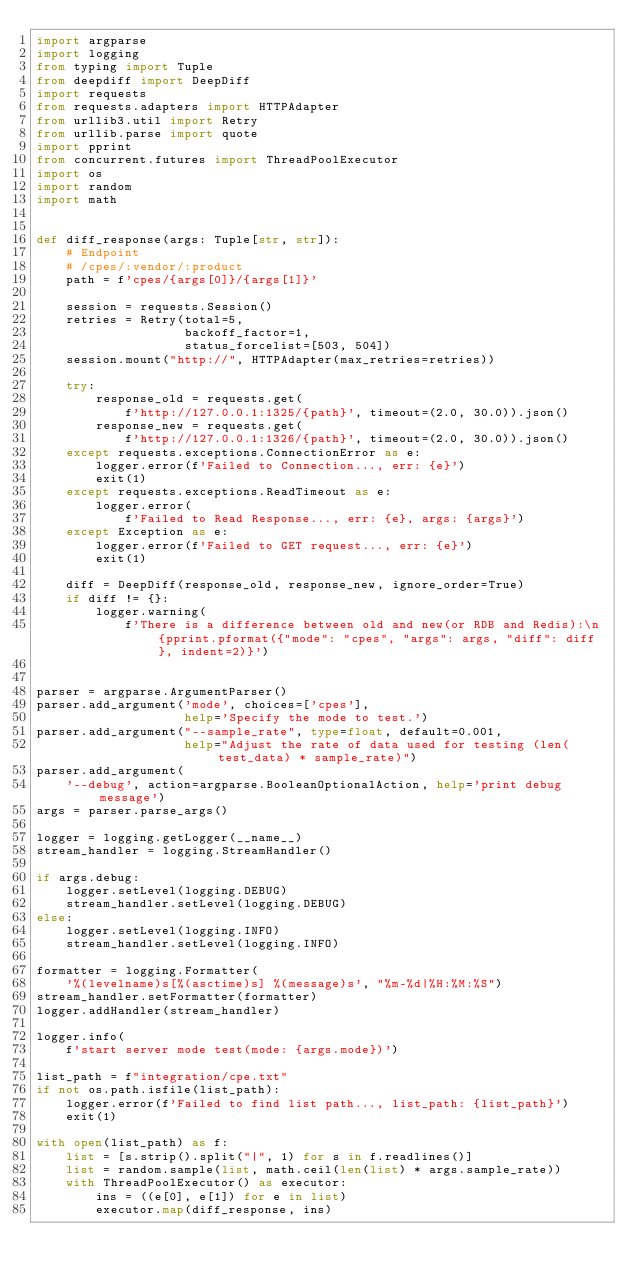<code> <loc_0><loc_0><loc_500><loc_500><_Python_>import argparse
import logging
from typing import Tuple
from deepdiff import DeepDiff
import requests
from requests.adapters import HTTPAdapter
from urllib3.util import Retry
from urllib.parse import quote
import pprint
from concurrent.futures import ThreadPoolExecutor
import os
import random
import math


def diff_response(args: Tuple[str, str]):
    # Endpoint
    # /cpes/:vendor/:product
    path = f'cpes/{args[0]}/{args[1]}'

    session = requests.Session()
    retries = Retry(total=5,
                    backoff_factor=1,
                    status_forcelist=[503, 504])
    session.mount("http://", HTTPAdapter(max_retries=retries))

    try:
        response_old = requests.get(
            f'http://127.0.0.1:1325/{path}', timeout=(2.0, 30.0)).json()
        response_new = requests.get(
            f'http://127.0.0.1:1326/{path}', timeout=(2.0, 30.0)).json()
    except requests.exceptions.ConnectionError as e:
        logger.error(f'Failed to Connection..., err: {e}')
        exit(1)
    except requests.exceptions.ReadTimeout as e:
        logger.error(
            f'Failed to Read Response..., err: {e}, args: {args}')
    except Exception as e:
        logger.error(f'Failed to GET request..., err: {e}')
        exit(1)

    diff = DeepDiff(response_old, response_new, ignore_order=True)
    if diff != {}:
        logger.warning(
            f'There is a difference between old and new(or RDB and Redis):\n {pprint.pformat({"mode": "cpes", "args": args, "diff": diff}, indent=2)}')


parser = argparse.ArgumentParser()
parser.add_argument('mode', choices=['cpes'],
                    help='Specify the mode to test.')
parser.add_argument("--sample_rate", type=float, default=0.001,
                    help="Adjust the rate of data used for testing (len(test_data) * sample_rate)")
parser.add_argument(
    '--debug', action=argparse.BooleanOptionalAction, help='print debug message')
args = parser.parse_args()

logger = logging.getLogger(__name__)
stream_handler = logging.StreamHandler()

if args.debug:
    logger.setLevel(logging.DEBUG)
    stream_handler.setLevel(logging.DEBUG)
else:
    logger.setLevel(logging.INFO)
    stream_handler.setLevel(logging.INFO)

formatter = logging.Formatter(
    '%(levelname)s[%(asctime)s] %(message)s', "%m-%d|%H:%M:%S")
stream_handler.setFormatter(formatter)
logger.addHandler(stream_handler)

logger.info(
    f'start server mode test(mode: {args.mode})')

list_path = f"integration/cpe.txt"
if not os.path.isfile(list_path):
    logger.error(f'Failed to find list path..., list_path: {list_path}')
    exit(1)

with open(list_path) as f:
    list = [s.strip().split("|", 1) for s in f.readlines()]
    list = random.sample(list, math.ceil(len(list) * args.sample_rate))
    with ThreadPoolExecutor() as executor:
        ins = ((e[0], e[1]) for e in list)
        executor.map(diff_response, ins)
</code> 